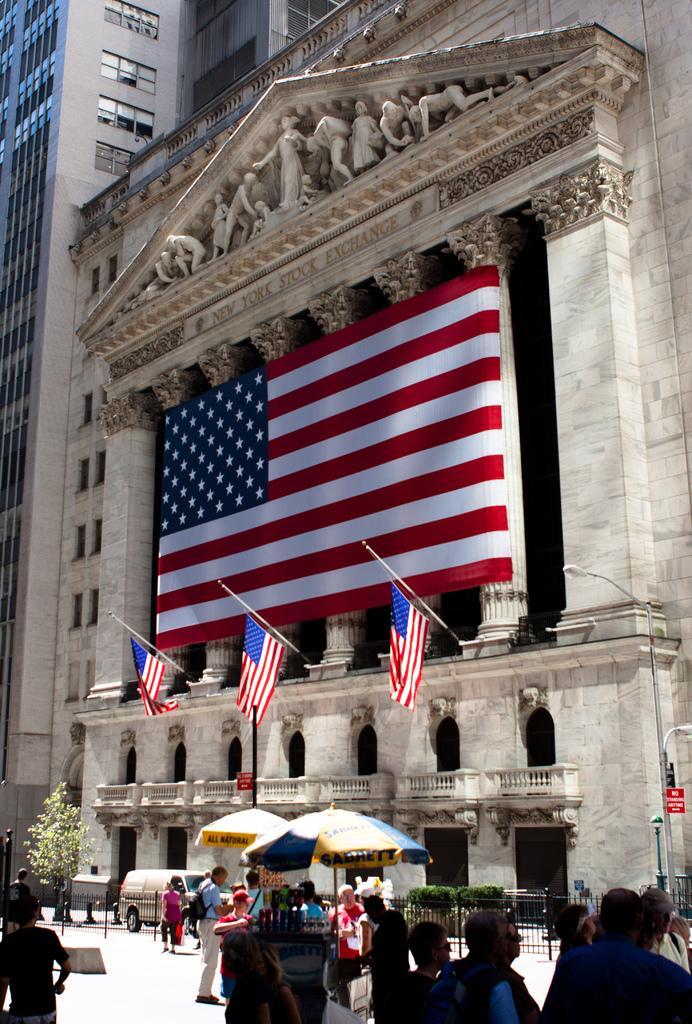Please provide a concise description of this image. In this picture there are few people and two stalls and there is a building in the background which has few flags on it. 